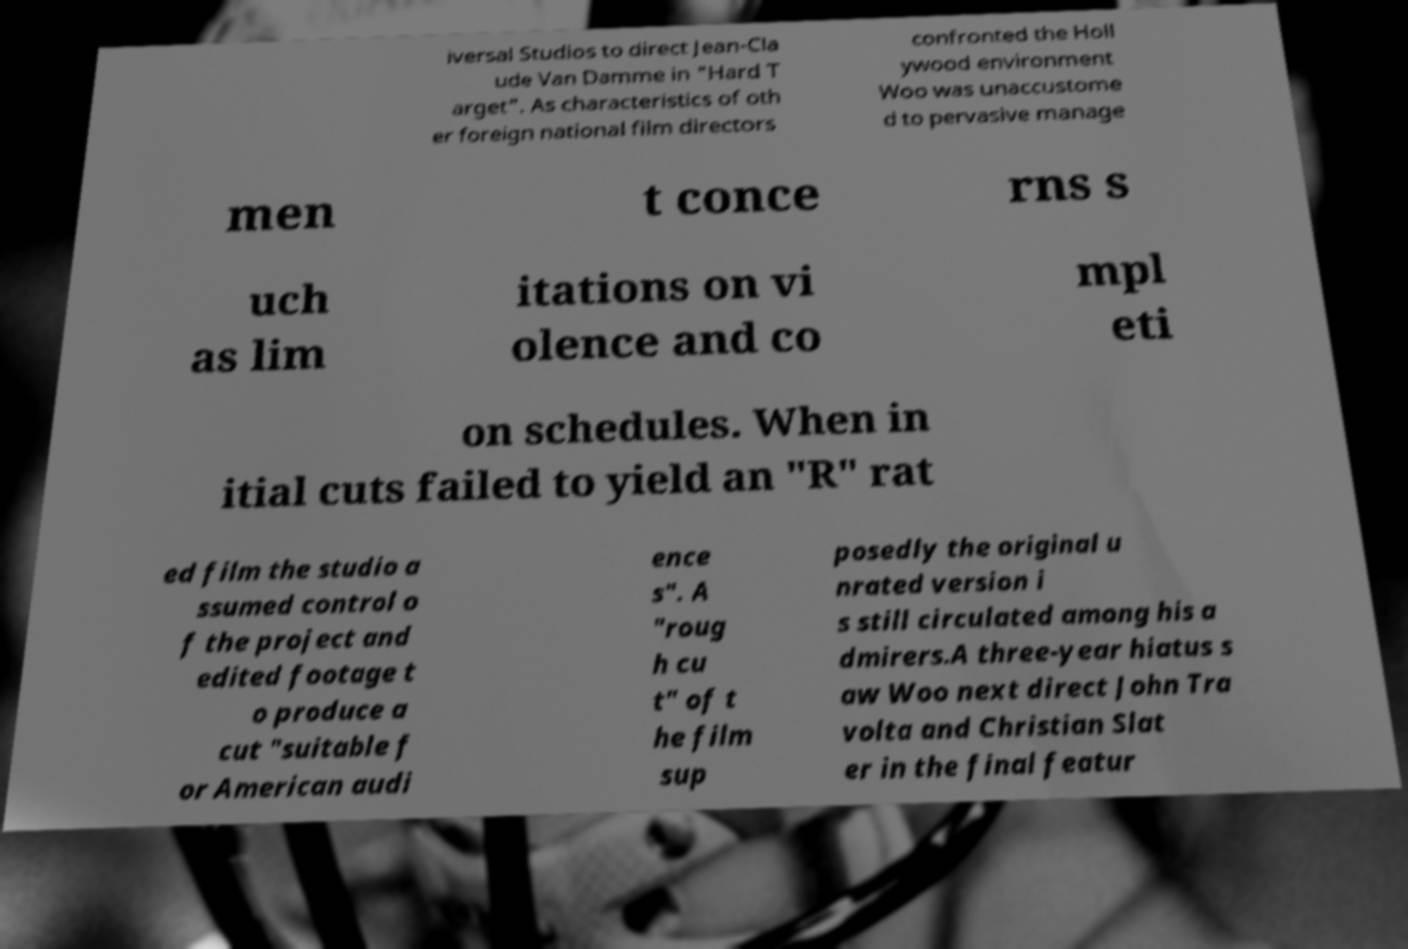There's text embedded in this image that I need extracted. Can you transcribe it verbatim? iversal Studios to direct Jean-Cla ude Van Damme in "Hard T arget". As characteristics of oth er foreign national film directors confronted the Holl ywood environment Woo was unaccustome d to pervasive manage men t conce rns s uch as lim itations on vi olence and co mpl eti on schedules. When in itial cuts failed to yield an "R" rat ed film the studio a ssumed control o f the project and edited footage t o produce a cut "suitable f or American audi ence s". A "roug h cu t" of t he film sup posedly the original u nrated version i s still circulated among his a dmirers.A three-year hiatus s aw Woo next direct John Tra volta and Christian Slat er in the final featur 